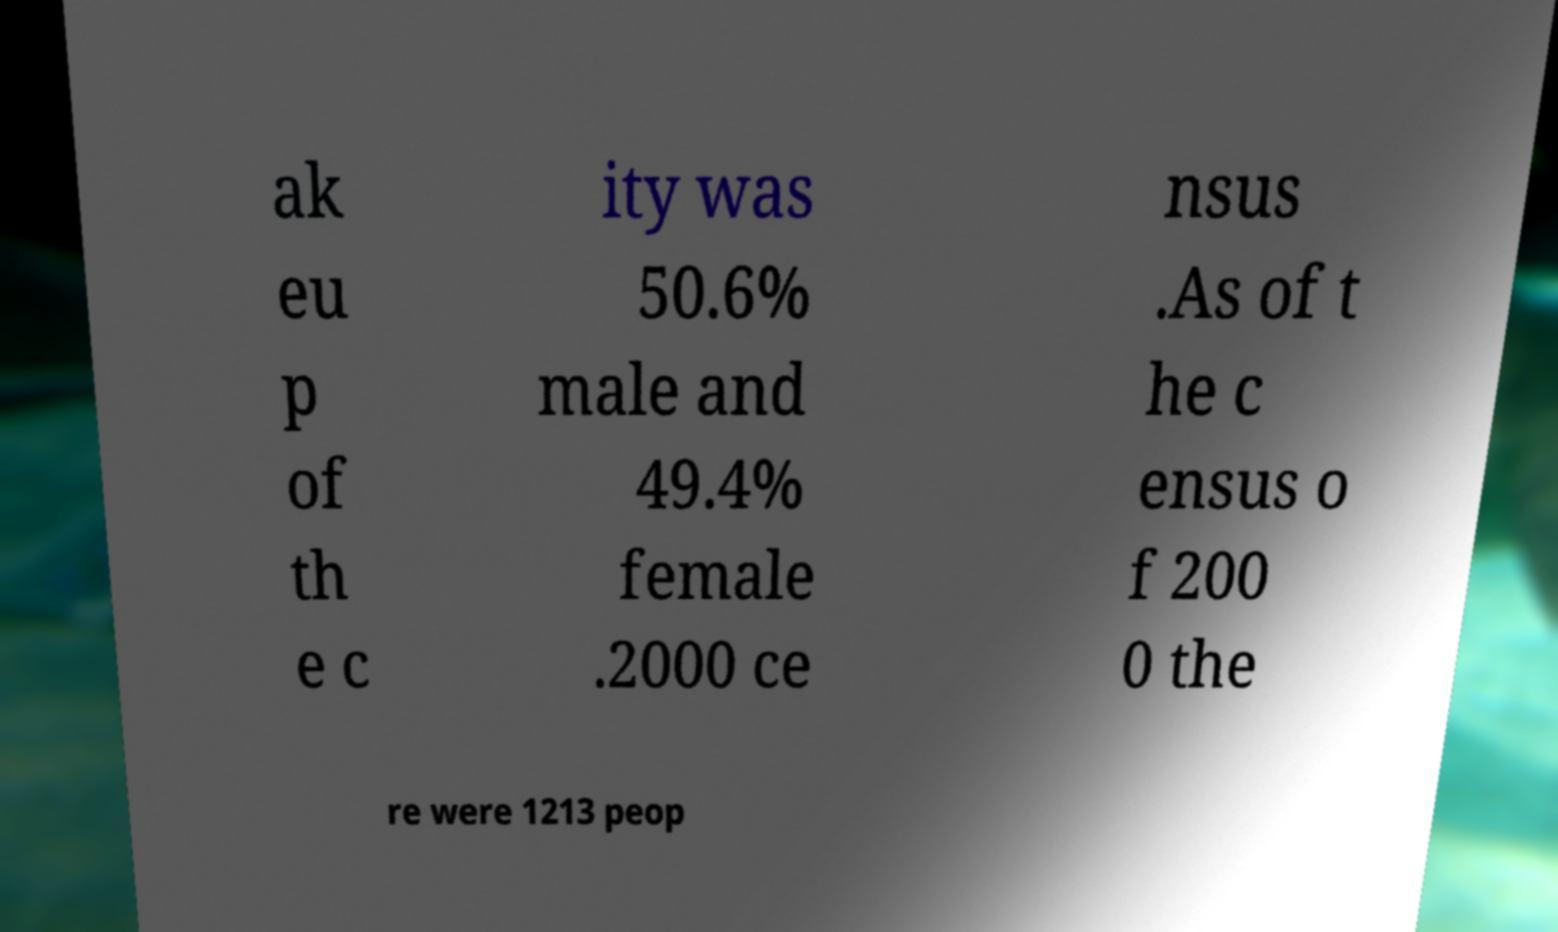Could you extract and type out the text from this image? ak eu p of th e c ity was 50.6% male and 49.4% female .2000 ce nsus .As of t he c ensus o f 200 0 the re were 1213 peop 